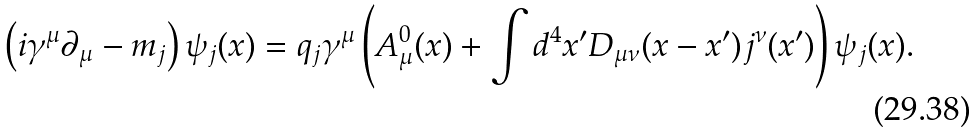<formula> <loc_0><loc_0><loc_500><loc_500>\left ( i \gamma ^ { \mu } \partial _ { \mu } - m _ { j } \right ) \psi _ { j } ( x ) = q _ { j } \gamma ^ { \mu } \left ( A _ { \mu } ^ { 0 } ( x ) + \int d ^ { 4 } x ^ { \prime } D _ { \mu \nu } ( x - x ^ { \prime } ) j ^ { \nu } ( x ^ { \prime } ) \right ) \psi _ { j } ( x ) .</formula> 